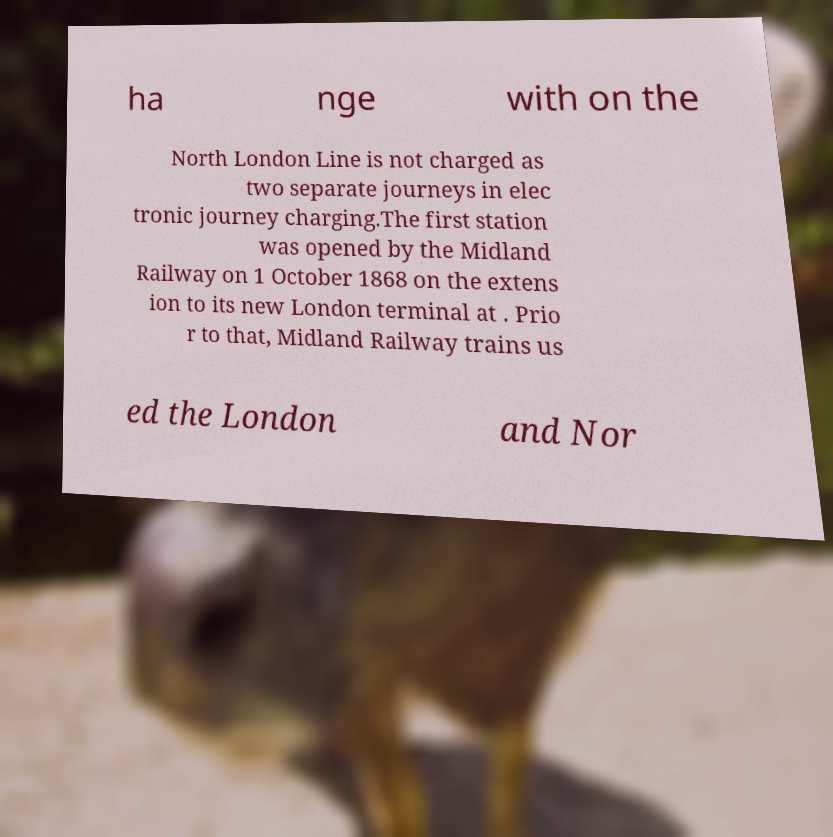Please read and relay the text visible in this image. What does it say? ha nge with on the North London Line is not charged as two separate journeys in elec tronic journey charging.The first station was opened by the Midland Railway on 1 October 1868 on the extens ion to its new London terminal at . Prio r to that, Midland Railway trains us ed the London and Nor 